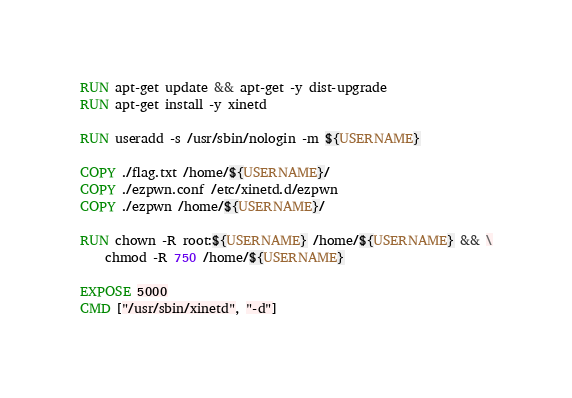<code> <loc_0><loc_0><loc_500><loc_500><_Dockerfile_>
RUN apt-get update && apt-get -y dist-upgrade
RUN apt-get install -y xinetd

RUN useradd -s /usr/sbin/nologin -m ${USERNAME}

COPY ./flag.txt /home/${USERNAME}/
COPY ./ezpwn.conf /etc/xinetd.d/ezpwn
COPY ./ezpwn /home/${USERNAME}/

RUN chown -R root:${USERNAME} /home/${USERNAME} && \
    chmod -R 750 /home/${USERNAME}

EXPOSE 5000
CMD ["/usr/sbin/xinetd", "-d"]</code> 